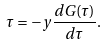<formula> <loc_0><loc_0><loc_500><loc_500>\tau = - y \frac { d G ( \tau ) } { d \tau } .</formula> 